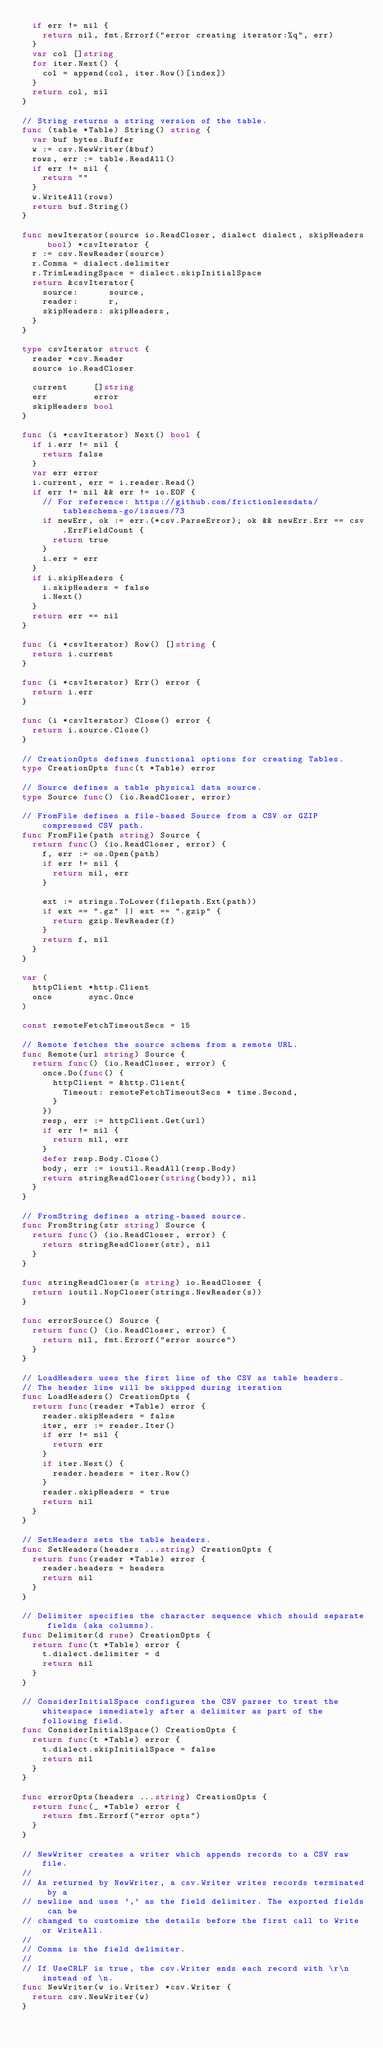<code> <loc_0><loc_0><loc_500><loc_500><_Go_>	if err != nil {
		return nil, fmt.Errorf("error creating iterator:%q", err)
	}
	var col []string
	for iter.Next() {
		col = append(col, iter.Row()[index])
	}
	return col, nil
}

// String returns a string version of the table.
func (table *Table) String() string {
	var buf bytes.Buffer
	w := csv.NewWriter(&buf)
	rows, err := table.ReadAll()
	if err != nil {
		return ""
	}
	w.WriteAll(rows)
	return buf.String()
}

func newIterator(source io.ReadCloser, dialect dialect, skipHeaders bool) *csvIterator {
	r := csv.NewReader(source)
	r.Comma = dialect.delimiter
	r.TrimLeadingSpace = dialect.skipInitialSpace
	return &csvIterator{
		source:      source,
		reader:      r,
		skipHeaders: skipHeaders,
	}
}

type csvIterator struct {
	reader *csv.Reader
	source io.ReadCloser

	current     []string
	err         error
	skipHeaders bool
}

func (i *csvIterator) Next() bool {
	if i.err != nil {
		return false
	}
	var err error
	i.current, err = i.reader.Read()
	if err != nil && err != io.EOF {
		// For reference: https://github.com/frictionlessdata/tableschema-go/issues/73
		if newErr, ok := err.(*csv.ParseError); ok && newErr.Err == csv.ErrFieldCount {
			return true
		}
		i.err = err
	}
	if i.skipHeaders {
		i.skipHeaders = false
		i.Next()
	}
	return err == nil
}

func (i *csvIterator) Row() []string {
	return i.current
}

func (i *csvIterator) Err() error {
	return i.err
}

func (i *csvIterator) Close() error {
	return i.source.Close()
}

// CreationOpts defines functional options for creating Tables.
type CreationOpts func(t *Table) error

// Source defines a table physical data source.
type Source func() (io.ReadCloser, error)

// FromFile defines a file-based Source from a CSV or GZIP compressed CSV path.
func FromFile(path string) Source {
	return func() (io.ReadCloser, error) {
		f, err := os.Open(path)
		if err != nil {
			return nil, err
		}

		ext := strings.ToLower(filepath.Ext(path))
		if ext == ".gz" || ext == ".gzip" {
			return gzip.NewReader(f)
		}
		return f, nil
	}
}

var (
	httpClient *http.Client
	once       sync.Once
)

const remoteFetchTimeoutSecs = 15

// Remote fetches the source schema from a remote URL.
func Remote(url string) Source {
	return func() (io.ReadCloser, error) {
		once.Do(func() {
			httpClient = &http.Client{
				Timeout: remoteFetchTimeoutSecs * time.Second,
			}
		})
		resp, err := httpClient.Get(url)
		if err != nil {
			return nil, err
		}
		defer resp.Body.Close()
		body, err := ioutil.ReadAll(resp.Body)
		return stringReadCloser(string(body)), nil
	}
}

// FromString defines a string-based source.
func FromString(str string) Source {
	return func() (io.ReadCloser, error) {
		return stringReadCloser(str), nil
	}
}

func stringReadCloser(s string) io.ReadCloser {
	return ioutil.NopCloser(strings.NewReader(s))
}

func errorSource() Source {
	return func() (io.ReadCloser, error) {
		return nil, fmt.Errorf("error source")
	}
}

// LoadHeaders uses the first line of the CSV as table headers.
// The header line will be skipped during iteration
func LoadHeaders() CreationOpts {
	return func(reader *Table) error {
		reader.skipHeaders = false
		iter, err := reader.Iter()
		if err != nil {
			return err
		}
		if iter.Next() {
			reader.headers = iter.Row()
		}
		reader.skipHeaders = true
		return nil
	}
}

// SetHeaders sets the table headers.
func SetHeaders(headers ...string) CreationOpts {
	return func(reader *Table) error {
		reader.headers = headers
		return nil
	}
}

// Delimiter specifies the character sequence which should separate fields (aka columns).
func Delimiter(d rune) CreationOpts {
	return func(t *Table) error {
		t.dialect.delimiter = d
		return nil
	}
}

// ConsiderInitialSpace configures the CSV parser to treat the whitespace immediately after a delimiter as part of the following field.
func ConsiderInitialSpace() CreationOpts {
	return func(t *Table) error {
		t.dialect.skipInitialSpace = false
		return nil
	}
}

func errorOpts(headers ...string) CreationOpts {
	return func(_ *Table) error {
		return fmt.Errorf("error opts")
	}
}

// NewWriter creates a writer which appends records to a CSV raw file.
//
// As returned by NewWriter, a csv.Writer writes records terminated by a
// newline and uses ',' as the field delimiter. The exported fields can be
// changed to customize the details before the first call to Write or WriteAll.
//
// Comma is the field delimiter.
//
// If UseCRLF is true, the csv.Writer ends each record with \r\n instead of \n.
func NewWriter(w io.Writer) *csv.Writer {
	return csv.NewWriter(w)
}
</code> 